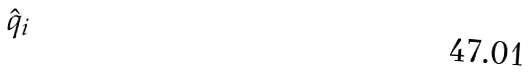Convert formula to latex. <formula><loc_0><loc_0><loc_500><loc_500>\hat { q } _ { i }</formula> 